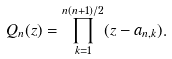Convert formula to latex. <formula><loc_0><loc_0><loc_500><loc_500>Q _ { n } ( z ) = \prod _ { k = 1 } ^ { n ( n + 1 ) / 2 } ( z - a _ { n , k } ) .</formula> 